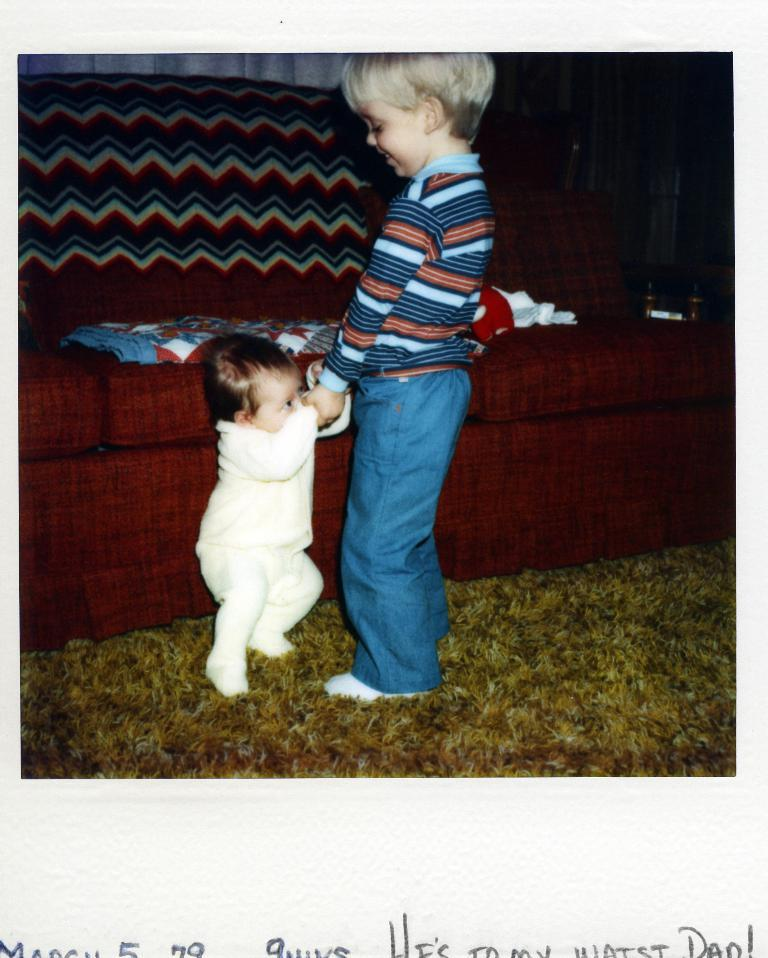Who are the subjects in the image? There is a boy and an infant in the image. What are the boy and the infant doing in the image? The boy is holding the hands of the infant. What is the setting of the image? The boy and the infant are standing on a carpet, and there is a couch in the background. What type of vegetable is the boy holding in the image? There is no vegetable present in the image; the boy is holding the hands of the infant. 